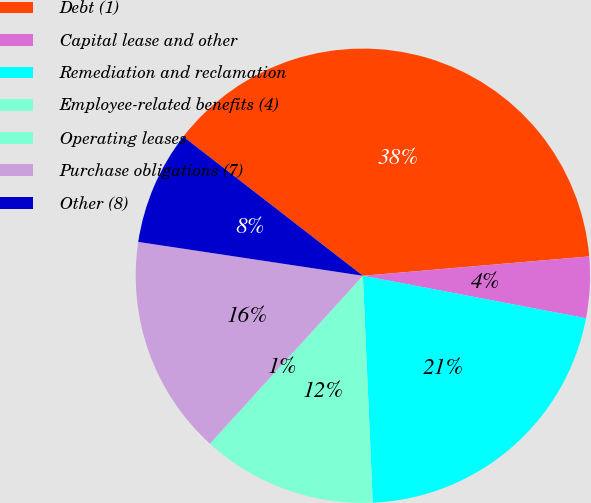<chart> <loc_0><loc_0><loc_500><loc_500><pie_chart><fcel>Debt (1)<fcel>Capital lease and other<fcel>Remediation and reclamation<fcel>Employee-related benefits (4)<fcel>Operating leases<fcel>Purchase obligations (7)<fcel>Other (8)<nl><fcel>38.15%<fcel>4.35%<fcel>21.31%<fcel>11.86%<fcel>0.59%<fcel>15.62%<fcel>8.11%<nl></chart> 